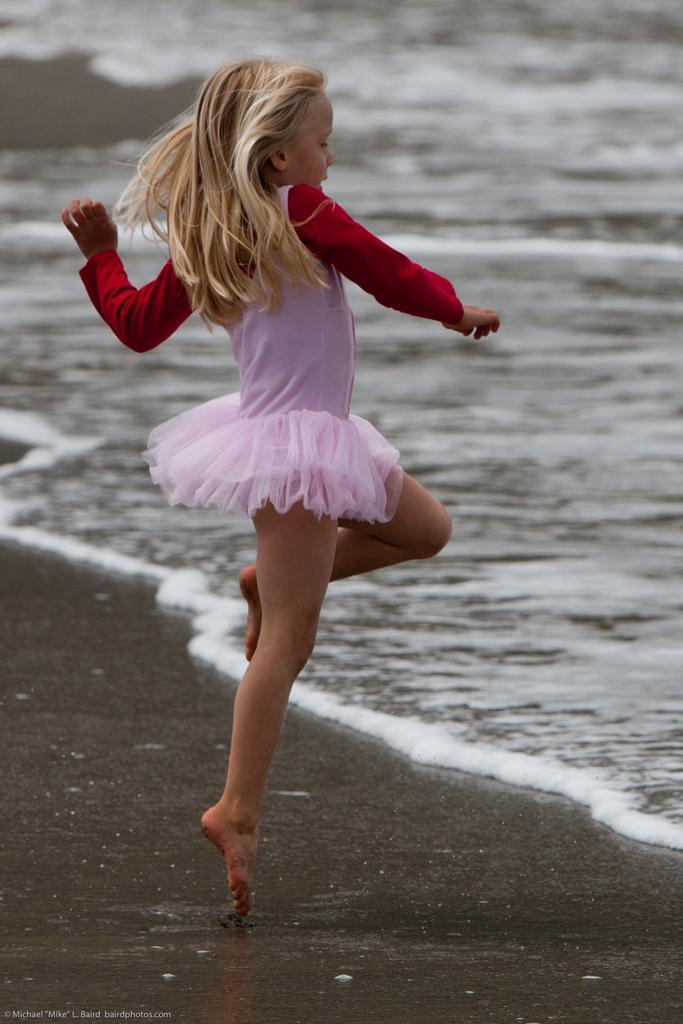Who is the main subject in the image? There is a girl in the center of the image. Where is the girl located in the image? The girl is on the sea shore. What can be seen in the background of the image? There is water visible in the background of the image. What type of basketball game is taking place in the image? There is no basketball game present in the image; it features a girl on the sea shore. Who is the girl meeting with in the image? The image does not depict a meeting; it simply shows a girl on the sea shore. 